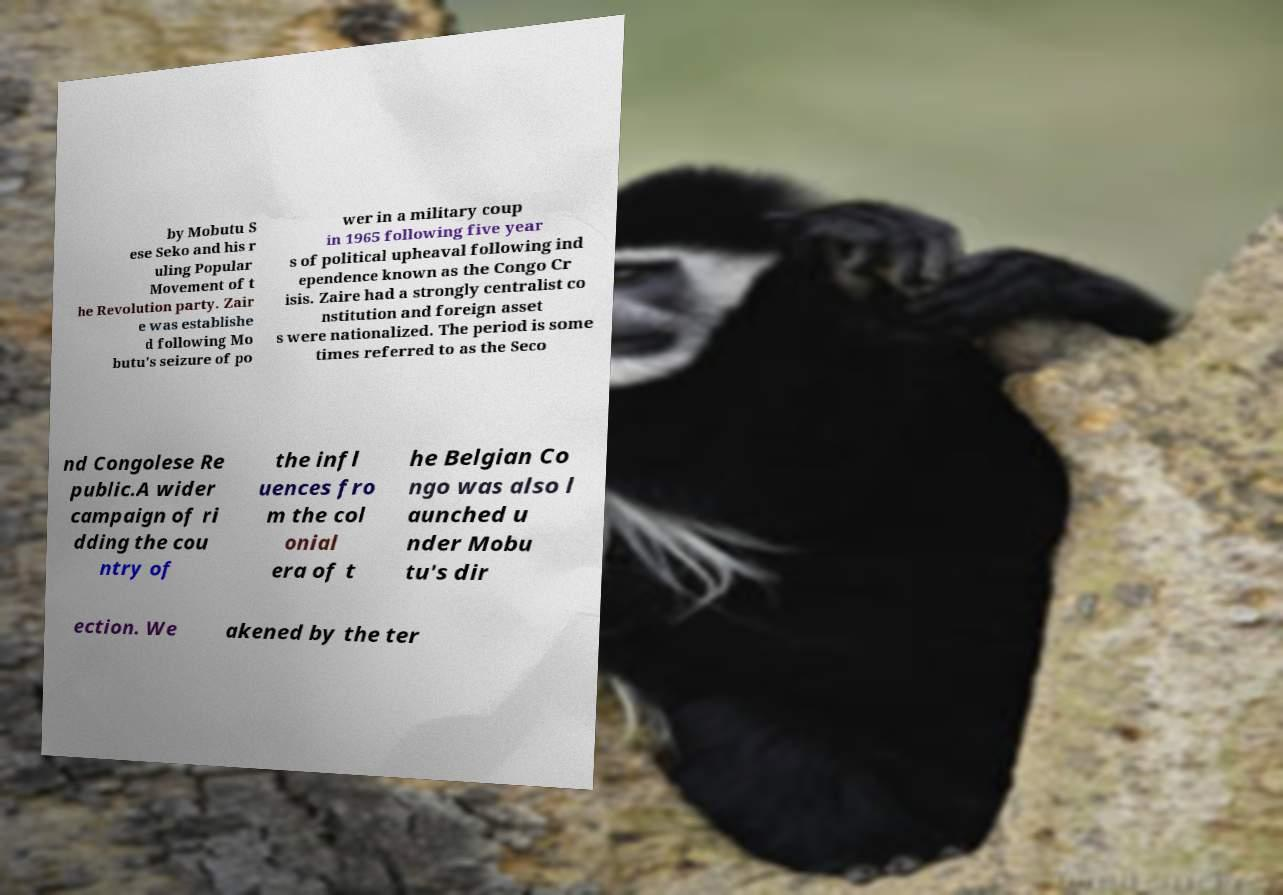I need the written content from this picture converted into text. Can you do that? by Mobutu S ese Seko and his r uling Popular Movement of t he Revolution party. Zair e was establishe d following Mo butu's seizure of po wer in a military coup in 1965 following five year s of political upheaval following ind ependence known as the Congo Cr isis. Zaire had a strongly centralist co nstitution and foreign asset s were nationalized. The period is some times referred to as the Seco nd Congolese Re public.A wider campaign of ri dding the cou ntry of the infl uences fro m the col onial era of t he Belgian Co ngo was also l aunched u nder Mobu tu's dir ection. We akened by the ter 